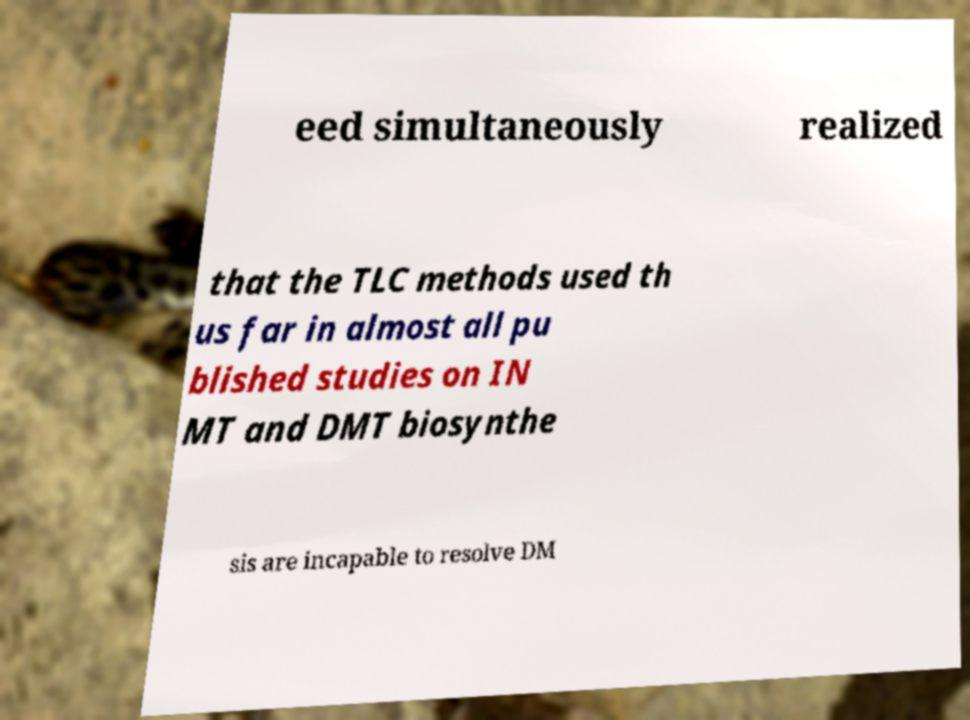Could you assist in decoding the text presented in this image and type it out clearly? eed simultaneously realized that the TLC methods used th us far in almost all pu blished studies on IN MT and DMT biosynthe sis are incapable to resolve DM 